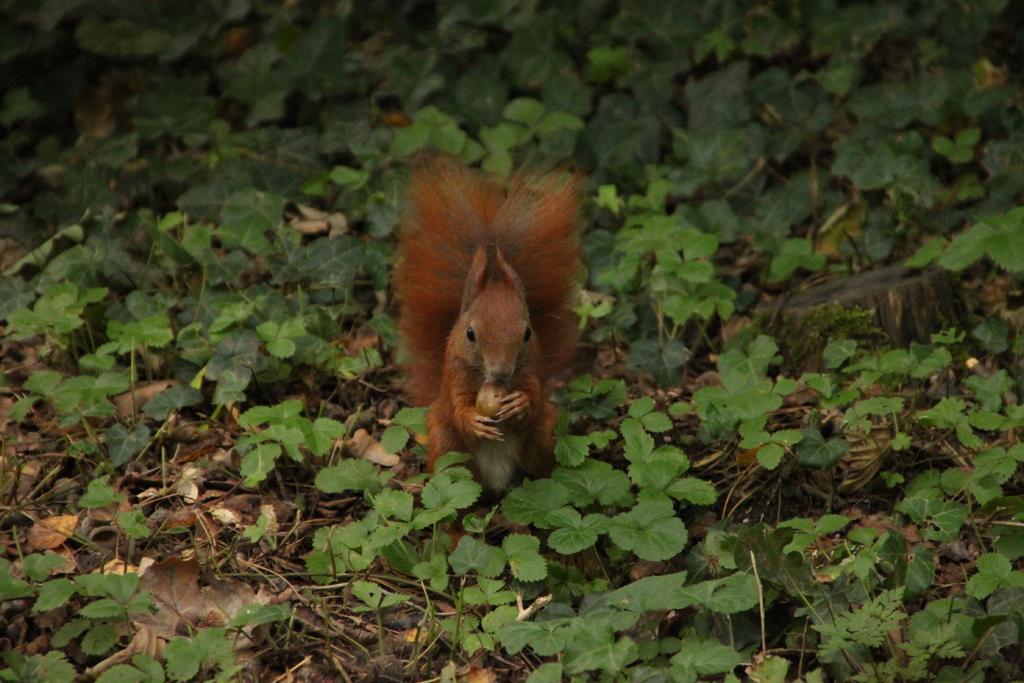How would you summarize this image in a sentence or two? In this image I can see an animal in black, brown and cream color and it is holding something. I can see few green plants, dry leaves and few sticks. 